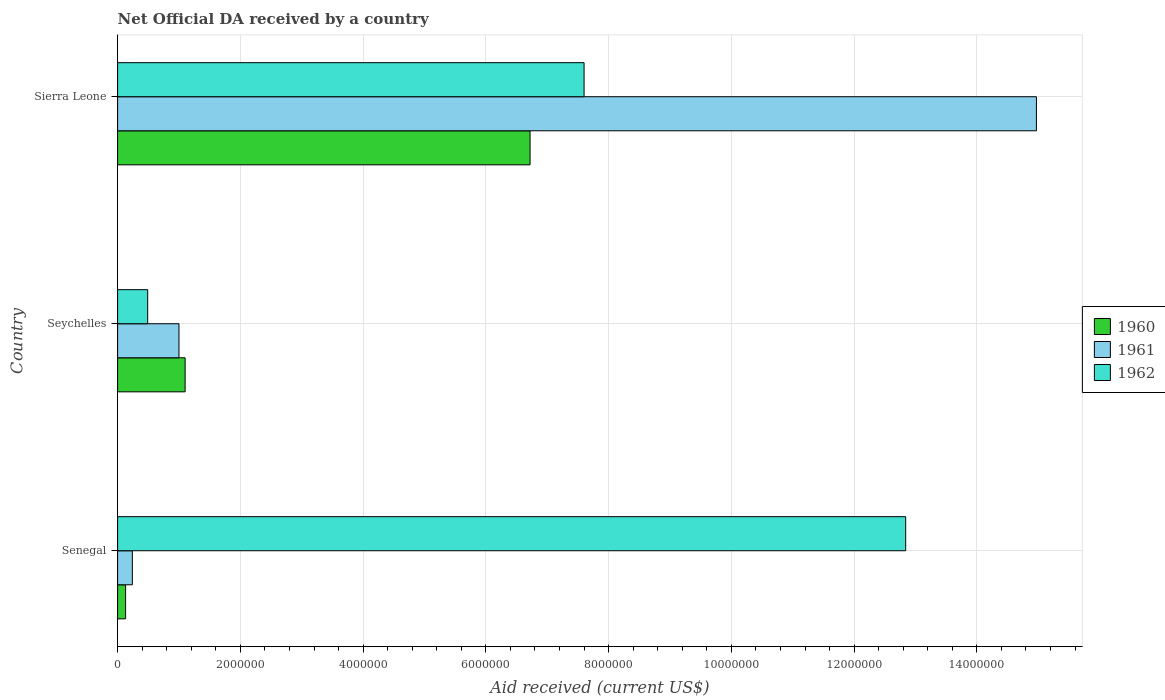How many bars are there on the 1st tick from the bottom?
Give a very brief answer. 3. What is the label of the 3rd group of bars from the top?
Offer a terse response. Senegal. In how many cases, is the number of bars for a given country not equal to the number of legend labels?
Offer a very short reply. 0. Across all countries, what is the maximum net official development assistance aid received in 1962?
Offer a terse response. 1.28e+07. Across all countries, what is the minimum net official development assistance aid received in 1961?
Offer a terse response. 2.40e+05. In which country was the net official development assistance aid received in 1961 maximum?
Ensure brevity in your answer.  Sierra Leone. In which country was the net official development assistance aid received in 1960 minimum?
Offer a terse response. Senegal. What is the total net official development assistance aid received in 1960 in the graph?
Your response must be concise. 7.95e+06. What is the difference between the net official development assistance aid received in 1961 in Senegal and that in Seychelles?
Offer a very short reply. -7.60e+05. What is the difference between the net official development assistance aid received in 1962 in Seychelles and the net official development assistance aid received in 1961 in Senegal?
Ensure brevity in your answer.  2.50e+05. What is the average net official development assistance aid received in 1962 per country?
Offer a terse response. 6.98e+06. What is the difference between the net official development assistance aid received in 1962 and net official development assistance aid received in 1961 in Senegal?
Keep it short and to the point. 1.26e+07. In how many countries, is the net official development assistance aid received in 1962 greater than 8800000 US$?
Your response must be concise. 1. What is the ratio of the net official development assistance aid received in 1962 in Seychelles to that in Sierra Leone?
Offer a terse response. 0.06. What is the difference between the highest and the second highest net official development assistance aid received in 1960?
Give a very brief answer. 5.62e+06. What is the difference between the highest and the lowest net official development assistance aid received in 1962?
Give a very brief answer. 1.24e+07. Is the sum of the net official development assistance aid received in 1960 in Seychelles and Sierra Leone greater than the maximum net official development assistance aid received in 1962 across all countries?
Ensure brevity in your answer.  No. Are all the bars in the graph horizontal?
Offer a very short reply. Yes. How many countries are there in the graph?
Provide a short and direct response. 3. What is the difference between two consecutive major ticks on the X-axis?
Your response must be concise. 2.00e+06. Are the values on the major ticks of X-axis written in scientific E-notation?
Offer a terse response. No. How are the legend labels stacked?
Give a very brief answer. Vertical. What is the title of the graph?
Provide a short and direct response. Net Official DA received by a country. Does "2004" appear as one of the legend labels in the graph?
Make the answer very short. No. What is the label or title of the X-axis?
Ensure brevity in your answer.  Aid received (current US$). What is the label or title of the Y-axis?
Make the answer very short. Country. What is the Aid received (current US$) in 1960 in Senegal?
Ensure brevity in your answer.  1.30e+05. What is the Aid received (current US$) in 1961 in Senegal?
Provide a short and direct response. 2.40e+05. What is the Aid received (current US$) in 1962 in Senegal?
Your response must be concise. 1.28e+07. What is the Aid received (current US$) of 1960 in Seychelles?
Your response must be concise. 1.10e+06. What is the Aid received (current US$) of 1961 in Seychelles?
Your response must be concise. 1.00e+06. What is the Aid received (current US$) in 1962 in Seychelles?
Keep it short and to the point. 4.90e+05. What is the Aid received (current US$) in 1960 in Sierra Leone?
Keep it short and to the point. 6.72e+06. What is the Aid received (current US$) of 1961 in Sierra Leone?
Provide a succinct answer. 1.50e+07. What is the Aid received (current US$) in 1962 in Sierra Leone?
Your answer should be very brief. 7.60e+06. Across all countries, what is the maximum Aid received (current US$) in 1960?
Provide a short and direct response. 6.72e+06. Across all countries, what is the maximum Aid received (current US$) of 1961?
Provide a succinct answer. 1.50e+07. Across all countries, what is the maximum Aid received (current US$) in 1962?
Your answer should be very brief. 1.28e+07. Across all countries, what is the minimum Aid received (current US$) in 1960?
Your answer should be very brief. 1.30e+05. Across all countries, what is the minimum Aid received (current US$) of 1962?
Your response must be concise. 4.90e+05. What is the total Aid received (current US$) in 1960 in the graph?
Ensure brevity in your answer.  7.95e+06. What is the total Aid received (current US$) in 1961 in the graph?
Keep it short and to the point. 1.62e+07. What is the total Aid received (current US$) in 1962 in the graph?
Give a very brief answer. 2.09e+07. What is the difference between the Aid received (current US$) of 1960 in Senegal and that in Seychelles?
Offer a very short reply. -9.70e+05. What is the difference between the Aid received (current US$) of 1961 in Senegal and that in Seychelles?
Give a very brief answer. -7.60e+05. What is the difference between the Aid received (current US$) in 1962 in Senegal and that in Seychelles?
Give a very brief answer. 1.24e+07. What is the difference between the Aid received (current US$) in 1960 in Senegal and that in Sierra Leone?
Keep it short and to the point. -6.59e+06. What is the difference between the Aid received (current US$) in 1961 in Senegal and that in Sierra Leone?
Your answer should be very brief. -1.47e+07. What is the difference between the Aid received (current US$) of 1962 in Senegal and that in Sierra Leone?
Provide a short and direct response. 5.24e+06. What is the difference between the Aid received (current US$) in 1960 in Seychelles and that in Sierra Leone?
Provide a short and direct response. -5.62e+06. What is the difference between the Aid received (current US$) in 1961 in Seychelles and that in Sierra Leone?
Your response must be concise. -1.40e+07. What is the difference between the Aid received (current US$) in 1962 in Seychelles and that in Sierra Leone?
Your answer should be compact. -7.11e+06. What is the difference between the Aid received (current US$) in 1960 in Senegal and the Aid received (current US$) in 1961 in Seychelles?
Make the answer very short. -8.70e+05. What is the difference between the Aid received (current US$) of 1960 in Senegal and the Aid received (current US$) of 1962 in Seychelles?
Provide a short and direct response. -3.60e+05. What is the difference between the Aid received (current US$) in 1961 in Senegal and the Aid received (current US$) in 1962 in Seychelles?
Your response must be concise. -2.50e+05. What is the difference between the Aid received (current US$) of 1960 in Senegal and the Aid received (current US$) of 1961 in Sierra Leone?
Give a very brief answer. -1.48e+07. What is the difference between the Aid received (current US$) in 1960 in Senegal and the Aid received (current US$) in 1962 in Sierra Leone?
Provide a short and direct response. -7.47e+06. What is the difference between the Aid received (current US$) of 1961 in Senegal and the Aid received (current US$) of 1962 in Sierra Leone?
Give a very brief answer. -7.36e+06. What is the difference between the Aid received (current US$) of 1960 in Seychelles and the Aid received (current US$) of 1961 in Sierra Leone?
Offer a very short reply. -1.39e+07. What is the difference between the Aid received (current US$) of 1960 in Seychelles and the Aid received (current US$) of 1962 in Sierra Leone?
Make the answer very short. -6.50e+06. What is the difference between the Aid received (current US$) in 1961 in Seychelles and the Aid received (current US$) in 1962 in Sierra Leone?
Provide a succinct answer. -6.60e+06. What is the average Aid received (current US$) in 1960 per country?
Your answer should be compact. 2.65e+06. What is the average Aid received (current US$) in 1961 per country?
Provide a short and direct response. 5.40e+06. What is the average Aid received (current US$) of 1962 per country?
Ensure brevity in your answer.  6.98e+06. What is the difference between the Aid received (current US$) in 1960 and Aid received (current US$) in 1962 in Senegal?
Ensure brevity in your answer.  -1.27e+07. What is the difference between the Aid received (current US$) of 1961 and Aid received (current US$) of 1962 in Senegal?
Offer a terse response. -1.26e+07. What is the difference between the Aid received (current US$) in 1960 and Aid received (current US$) in 1962 in Seychelles?
Offer a very short reply. 6.10e+05. What is the difference between the Aid received (current US$) in 1961 and Aid received (current US$) in 1962 in Seychelles?
Your response must be concise. 5.10e+05. What is the difference between the Aid received (current US$) in 1960 and Aid received (current US$) in 1961 in Sierra Leone?
Your answer should be compact. -8.25e+06. What is the difference between the Aid received (current US$) in 1960 and Aid received (current US$) in 1962 in Sierra Leone?
Provide a short and direct response. -8.80e+05. What is the difference between the Aid received (current US$) in 1961 and Aid received (current US$) in 1962 in Sierra Leone?
Your answer should be compact. 7.37e+06. What is the ratio of the Aid received (current US$) of 1960 in Senegal to that in Seychelles?
Provide a short and direct response. 0.12. What is the ratio of the Aid received (current US$) in 1961 in Senegal to that in Seychelles?
Your answer should be compact. 0.24. What is the ratio of the Aid received (current US$) in 1962 in Senegal to that in Seychelles?
Provide a short and direct response. 26.2. What is the ratio of the Aid received (current US$) in 1960 in Senegal to that in Sierra Leone?
Your answer should be compact. 0.02. What is the ratio of the Aid received (current US$) in 1961 in Senegal to that in Sierra Leone?
Offer a terse response. 0.02. What is the ratio of the Aid received (current US$) in 1962 in Senegal to that in Sierra Leone?
Provide a succinct answer. 1.69. What is the ratio of the Aid received (current US$) in 1960 in Seychelles to that in Sierra Leone?
Provide a short and direct response. 0.16. What is the ratio of the Aid received (current US$) of 1961 in Seychelles to that in Sierra Leone?
Provide a succinct answer. 0.07. What is the ratio of the Aid received (current US$) in 1962 in Seychelles to that in Sierra Leone?
Your response must be concise. 0.06. What is the difference between the highest and the second highest Aid received (current US$) of 1960?
Your response must be concise. 5.62e+06. What is the difference between the highest and the second highest Aid received (current US$) of 1961?
Keep it short and to the point. 1.40e+07. What is the difference between the highest and the second highest Aid received (current US$) of 1962?
Offer a terse response. 5.24e+06. What is the difference between the highest and the lowest Aid received (current US$) in 1960?
Give a very brief answer. 6.59e+06. What is the difference between the highest and the lowest Aid received (current US$) of 1961?
Your answer should be compact. 1.47e+07. What is the difference between the highest and the lowest Aid received (current US$) of 1962?
Keep it short and to the point. 1.24e+07. 